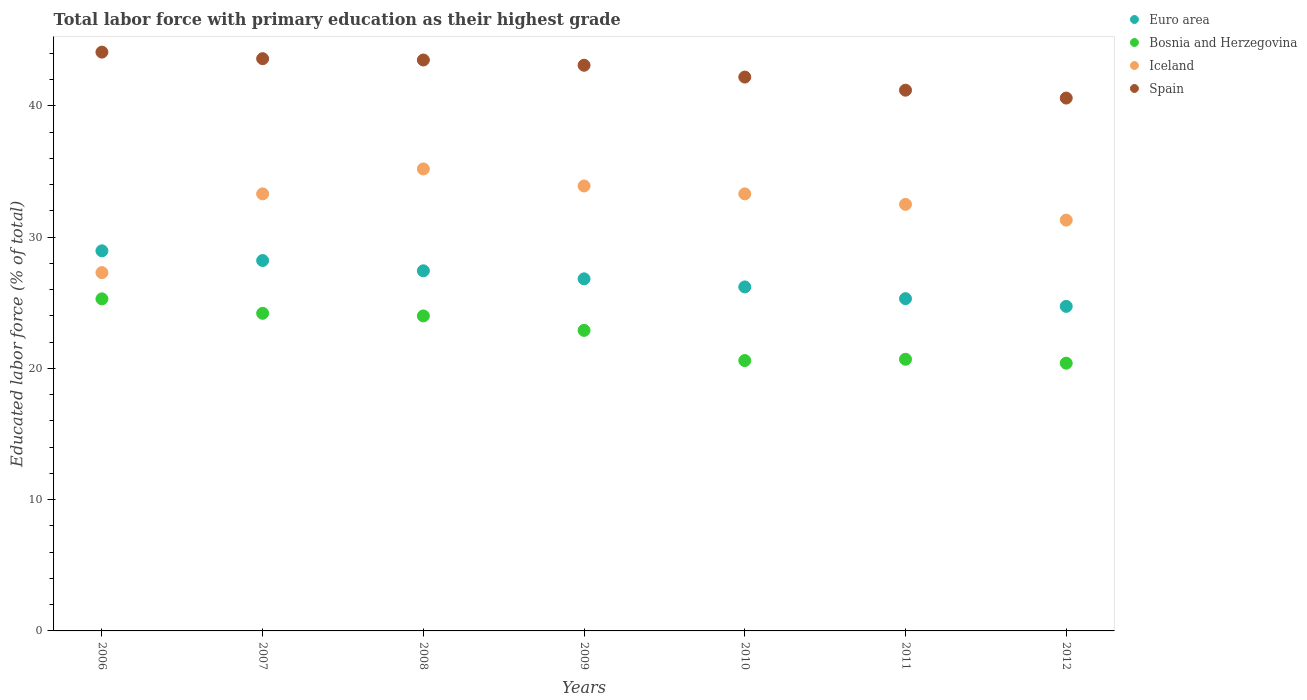How many different coloured dotlines are there?
Provide a succinct answer. 4. Is the number of dotlines equal to the number of legend labels?
Provide a succinct answer. Yes. What is the percentage of total labor force with primary education in Euro area in 2010?
Your answer should be compact. 26.21. Across all years, what is the maximum percentage of total labor force with primary education in Iceland?
Give a very brief answer. 35.2. Across all years, what is the minimum percentage of total labor force with primary education in Iceland?
Your response must be concise. 27.3. What is the total percentage of total labor force with primary education in Euro area in the graph?
Keep it short and to the point. 187.7. What is the difference between the percentage of total labor force with primary education in Spain in 2006 and that in 2011?
Your answer should be very brief. 2.9. What is the difference between the percentage of total labor force with primary education in Euro area in 2011 and the percentage of total labor force with primary education in Iceland in 2008?
Your response must be concise. -9.88. What is the average percentage of total labor force with primary education in Iceland per year?
Give a very brief answer. 32.4. In the year 2007, what is the difference between the percentage of total labor force with primary education in Euro area and percentage of total labor force with primary education in Bosnia and Herzegovina?
Your response must be concise. 4.02. In how many years, is the percentage of total labor force with primary education in Euro area greater than 8 %?
Provide a short and direct response. 7. What is the ratio of the percentage of total labor force with primary education in Euro area in 2010 to that in 2012?
Offer a very short reply. 1.06. Is the percentage of total labor force with primary education in Spain in 2008 less than that in 2010?
Ensure brevity in your answer.  No. Is the difference between the percentage of total labor force with primary education in Euro area in 2007 and 2012 greater than the difference between the percentage of total labor force with primary education in Bosnia and Herzegovina in 2007 and 2012?
Give a very brief answer. No. What is the difference between the highest and the second highest percentage of total labor force with primary education in Iceland?
Provide a short and direct response. 1.3. What is the difference between the highest and the lowest percentage of total labor force with primary education in Euro area?
Your answer should be compact. 4.23. Is it the case that in every year, the sum of the percentage of total labor force with primary education in Bosnia and Herzegovina and percentage of total labor force with primary education in Euro area  is greater than the sum of percentage of total labor force with primary education in Spain and percentage of total labor force with primary education in Iceland?
Provide a succinct answer. Yes. Is it the case that in every year, the sum of the percentage of total labor force with primary education in Iceland and percentage of total labor force with primary education in Euro area  is greater than the percentage of total labor force with primary education in Spain?
Your response must be concise. Yes. Is the percentage of total labor force with primary education in Spain strictly greater than the percentage of total labor force with primary education in Bosnia and Herzegovina over the years?
Provide a short and direct response. Yes. Does the graph contain any zero values?
Your answer should be very brief. No. Where does the legend appear in the graph?
Offer a terse response. Top right. How many legend labels are there?
Provide a short and direct response. 4. How are the legend labels stacked?
Make the answer very short. Vertical. What is the title of the graph?
Offer a terse response. Total labor force with primary education as their highest grade. Does "Israel" appear as one of the legend labels in the graph?
Keep it short and to the point. No. What is the label or title of the Y-axis?
Provide a short and direct response. Educated labor force (% of total). What is the Educated labor force (% of total) in Euro area in 2006?
Offer a terse response. 28.96. What is the Educated labor force (% of total) of Bosnia and Herzegovina in 2006?
Offer a terse response. 25.3. What is the Educated labor force (% of total) in Iceland in 2006?
Ensure brevity in your answer.  27.3. What is the Educated labor force (% of total) of Spain in 2006?
Offer a terse response. 44.1. What is the Educated labor force (% of total) of Euro area in 2007?
Keep it short and to the point. 28.22. What is the Educated labor force (% of total) of Bosnia and Herzegovina in 2007?
Your answer should be compact. 24.2. What is the Educated labor force (% of total) in Iceland in 2007?
Offer a terse response. 33.3. What is the Educated labor force (% of total) in Spain in 2007?
Keep it short and to the point. 43.6. What is the Educated labor force (% of total) in Euro area in 2008?
Offer a terse response. 27.44. What is the Educated labor force (% of total) of Bosnia and Herzegovina in 2008?
Keep it short and to the point. 24. What is the Educated labor force (% of total) of Iceland in 2008?
Offer a very short reply. 35.2. What is the Educated labor force (% of total) of Spain in 2008?
Provide a short and direct response. 43.5. What is the Educated labor force (% of total) in Euro area in 2009?
Make the answer very short. 26.83. What is the Educated labor force (% of total) in Bosnia and Herzegovina in 2009?
Offer a terse response. 22.9. What is the Educated labor force (% of total) of Iceland in 2009?
Provide a short and direct response. 33.9. What is the Educated labor force (% of total) of Spain in 2009?
Make the answer very short. 43.1. What is the Educated labor force (% of total) in Euro area in 2010?
Your answer should be very brief. 26.21. What is the Educated labor force (% of total) of Bosnia and Herzegovina in 2010?
Your response must be concise. 20.6. What is the Educated labor force (% of total) in Iceland in 2010?
Your answer should be compact. 33.3. What is the Educated labor force (% of total) in Spain in 2010?
Offer a very short reply. 42.2. What is the Educated labor force (% of total) in Euro area in 2011?
Make the answer very short. 25.32. What is the Educated labor force (% of total) of Bosnia and Herzegovina in 2011?
Offer a very short reply. 20.7. What is the Educated labor force (% of total) of Iceland in 2011?
Your response must be concise. 32.5. What is the Educated labor force (% of total) of Spain in 2011?
Your answer should be very brief. 41.2. What is the Educated labor force (% of total) of Euro area in 2012?
Provide a short and direct response. 24.73. What is the Educated labor force (% of total) in Bosnia and Herzegovina in 2012?
Give a very brief answer. 20.4. What is the Educated labor force (% of total) of Iceland in 2012?
Ensure brevity in your answer.  31.3. What is the Educated labor force (% of total) in Spain in 2012?
Offer a very short reply. 40.6. Across all years, what is the maximum Educated labor force (% of total) of Euro area?
Provide a succinct answer. 28.96. Across all years, what is the maximum Educated labor force (% of total) in Bosnia and Herzegovina?
Your answer should be compact. 25.3. Across all years, what is the maximum Educated labor force (% of total) in Iceland?
Offer a terse response. 35.2. Across all years, what is the maximum Educated labor force (% of total) in Spain?
Provide a short and direct response. 44.1. Across all years, what is the minimum Educated labor force (% of total) of Euro area?
Provide a succinct answer. 24.73. Across all years, what is the minimum Educated labor force (% of total) of Bosnia and Herzegovina?
Keep it short and to the point. 20.4. Across all years, what is the minimum Educated labor force (% of total) of Iceland?
Your answer should be very brief. 27.3. Across all years, what is the minimum Educated labor force (% of total) in Spain?
Ensure brevity in your answer.  40.6. What is the total Educated labor force (% of total) in Euro area in the graph?
Offer a terse response. 187.7. What is the total Educated labor force (% of total) of Bosnia and Herzegovina in the graph?
Ensure brevity in your answer.  158.1. What is the total Educated labor force (% of total) of Iceland in the graph?
Your answer should be very brief. 226.8. What is the total Educated labor force (% of total) in Spain in the graph?
Make the answer very short. 298.3. What is the difference between the Educated labor force (% of total) of Euro area in 2006 and that in 2007?
Your answer should be compact. 0.74. What is the difference between the Educated labor force (% of total) of Spain in 2006 and that in 2007?
Your answer should be very brief. 0.5. What is the difference between the Educated labor force (% of total) in Euro area in 2006 and that in 2008?
Make the answer very short. 1.52. What is the difference between the Educated labor force (% of total) of Bosnia and Herzegovina in 2006 and that in 2008?
Offer a terse response. 1.3. What is the difference between the Educated labor force (% of total) of Iceland in 2006 and that in 2008?
Provide a succinct answer. -7.9. What is the difference between the Educated labor force (% of total) in Spain in 2006 and that in 2008?
Provide a succinct answer. 0.6. What is the difference between the Educated labor force (% of total) in Euro area in 2006 and that in 2009?
Give a very brief answer. 2.13. What is the difference between the Educated labor force (% of total) in Euro area in 2006 and that in 2010?
Offer a very short reply. 2.75. What is the difference between the Educated labor force (% of total) in Spain in 2006 and that in 2010?
Offer a terse response. 1.9. What is the difference between the Educated labor force (% of total) in Euro area in 2006 and that in 2011?
Offer a very short reply. 3.64. What is the difference between the Educated labor force (% of total) of Euro area in 2006 and that in 2012?
Provide a short and direct response. 4.23. What is the difference between the Educated labor force (% of total) in Bosnia and Herzegovina in 2006 and that in 2012?
Provide a short and direct response. 4.9. What is the difference between the Educated labor force (% of total) of Iceland in 2006 and that in 2012?
Your response must be concise. -4. What is the difference between the Educated labor force (% of total) of Spain in 2006 and that in 2012?
Your answer should be compact. 3.5. What is the difference between the Educated labor force (% of total) in Euro area in 2007 and that in 2008?
Offer a very short reply. 0.78. What is the difference between the Educated labor force (% of total) in Bosnia and Herzegovina in 2007 and that in 2008?
Ensure brevity in your answer.  0.2. What is the difference between the Educated labor force (% of total) in Iceland in 2007 and that in 2008?
Offer a very short reply. -1.9. What is the difference between the Educated labor force (% of total) in Euro area in 2007 and that in 2009?
Give a very brief answer. 1.4. What is the difference between the Educated labor force (% of total) in Euro area in 2007 and that in 2010?
Your response must be concise. 2.01. What is the difference between the Educated labor force (% of total) in Bosnia and Herzegovina in 2007 and that in 2010?
Give a very brief answer. 3.6. What is the difference between the Educated labor force (% of total) of Euro area in 2007 and that in 2011?
Offer a very short reply. 2.9. What is the difference between the Educated labor force (% of total) of Bosnia and Herzegovina in 2007 and that in 2011?
Your answer should be compact. 3.5. What is the difference between the Educated labor force (% of total) of Iceland in 2007 and that in 2011?
Your response must be concise. 0.8. What is the difference between the Educated labor force (% of total) of Euro area in 2007 and that in 2012?
Provide a short and direct response. 3.49. What is the difference between the Educated labor force (% of total) in Iceland in 2007 and that in 2012?
Keep it short and to the point. 2. What is the difference between the Educated labor force (% of total) in Euro area in 2008 and that in 2009?
Offer a terse response. 0.61. What is the difference between the Educated labor force (% of total) in Spain in 2008 and that in 2009?
Give a very brief answer. 0.4. What is the difference between the Educated labor force (% of total) of Euro area in 2008 and that in 2010?
Ensure brevity in your answer.  1.23. What is the difference between the Educated labor force (% of total) of Bosnia and Herzegovina in 2008 and that in 2010?
Ensure brevity in your answer.  3.4. What is the difference between the Educated labor force (% of total) of Spain in 2008 and that in 2010?
Your answer should be compact. 1.3. What is the difference between the Educated labor force (% of total) of Euro area in 2008 and that in 2011?
Ensure brevity in your answer.  2.12. What is the difference between the Educated labor force (% of total) in Iceland in 2008 and that in 2011?
Your answer should be very brief. 2.7. What is the difference between the Educated labor force (% of total) of Euro area in 2008 and that in 2012?
Provide a short and direct response. 2.71. What is the difference between the Educated labor force (% of total) in Iceland in 2008 and that in 2012?
Keep it short and to the point. 3.9. What is the difference between the Educated labor force (% of total) in Spain in 2008 and that in 2012?
Your answer should be compact. 2.9. What is the difference between the Educated labor force (% of total) in Euro area in 2009 and that in 2010?
Offer a terse response. 0.62. What is the difference between the Educated labor force (% of total) in Bosnia and Herzegovina in 2009 and that in 2010?
Your response must be concise. 2.3. What is the difference between the Educated labor force (% of total) in Spain in 2009 and that in 2010?
Your answer should be compact. 0.9. What is the difference between the Educated labor force (% of total) in Euro area in 2009 and that in 2011?
Offer a very short reply. 1.51. What is the difference between the Educated labor force (% of total) in Bosnia and Herzegovina in 2009 and that in 2011?
Provide a succinct answer. 2.2. What is the difference between the Educated labor force (% of total) of Euro area in 2009 and that in 2012?
Your response must be concise. 2.1. What is the difference between the Educated labor force (% of total) of Bosnia and Herzegovina in 2009 and that in 2012?
Keep it short and to the point. 2.5. What is the difference between the Educated labor force (% of total) in Iceland in 2009 and that in 2012?
Offer a very short reply. 2.6. What is the difference between the Educated labor force (% of total) of Spain in 2009 and that in 2012?
Your answer should be very brief. 2.5. What is the difference between the Educated labor force (% of total) in Euro area in 2010 and that in 2011?
Keep it short and to the point. 0.89. What is the difference between the Educated labor force (% of total) of Bosnia and Herzegovina in 2010 and that in 2011?
Your answer should be very brief. -0.1. What is the difference between the Educated labor force (% of total) of Iceland in 2010 and that in 2011?
Provide a short and direct response. 0.8. What is the difference between the Educated labor force (% of total) of Euro area in 2010 and that in 2012?
Offer a very short reply. 1.48. What is the difference between the Educated labor force (% of total) of Bosnia and Herzegovina in 2010 and that in 2012?
Offer a very short reply. 0.2. What is the difference between the Educated labor force (% of total) of Euro area in 2011 and that in 2012?
Keep it short and to the point. 0.59. What is the difference between the Educated labor force (% of total) of Spain in 2011 and that in 2012?
Give a very brief answer. 0.6. What is the difference between the Educated labor force (% of total) of Euro area in 2006 and the Educated labor force (% of total) of Bosnia and Herzegovina in 2007?
Make the answer very short. 4.76. What is the difference between the Educated labor force (% of total) in Euro area in 2006 and the Educated labor force (% of total) in Iceland in 2007?
Provide a short and direct response. -4.34. What is the difference between the Educated labor force (% of total) in Euro area in 2006 and the Educated labor force (% of total) in Spain in 2007?
Provide a short and direct response. -14.64. What is the difference between the Educated labor force (% of total) of Bosnia and Herzegovina in 2006 and the Educated labor force (% of total) of Spain in 2007?
Keep it short and to the point. -18.3. What is the difference between the Educated labor force (% of total) in Iceland in 2006 and the Educated labor force (% of total) in Spain in 2007?
Offer a terse response. -16.3. What is the difference between the Educated labor force (% of total) in Euro area in 2006 and the Educated labor force (% of total) in Bosnia and Herzegovina in 2008?
Ensure brevity in your answer.  4.96. What is the difference between the Educated labor force (% of total) in Euro area in 2006 and the Educated labor force (% of total) in Iceland in 2008?
Your answer should be compact. -6.24. What is the difference between the Educated labor force (% of total) in Euro area in 2006 and the Educated labor force (% of total) in Spain in 2008?
Your answer should be very brief. -14.54. What is the difference between the Educated labor force (% of total) of Bosnia and Herzegovina in 2006 and the Educated labor force (% of total) of Spain in 2008?
Provide a short and direct response. -18.2. What is the difference between the Educated labor force (% of total) of Iceland in 2006 and the Educated labor force (% of total) of Spain in 2008?
Your response must be concise. -16.2. What is the difference between the Educated labor force (% of total) of Euro area in 2006 and the Educated labor force (% of total) of Bosnia and Herzegovina in 2009?
Your answer should be compact. 6.06. What is the difference between the Educated labor force (% of total) of Euro area in 2006 and the Educated labor force (% of total) of Iceland in 2009?
Offer a terse response. -4.94. What is the difference between the Educated labor force (% of total) in Euro area in 2006 and the Educated labor force (% of total) in Spain in 2009?
Provide a short and direct response. -14.14. What is the difference between the Educated labor force (% of total) in Bosnia and Herzegovina in 2006 and the Educated labor force (% of total) in Iceland in 2009?
Offer a very short reply. -8.6. What is the difference between the Educated labor force (% of total) in Bosnia and Herzegovina in 2006 and the Educated labor force (% of total) in Spain in 2009?
Offer a terse response. -17.8. What is the difference between the Educated labor force (% of total) in Iceland in 2006 and the Educated labor force (% of total) in Spain in 2009?
Your answer should be compact. -15.8. What is the difference between the Educated labor force (% of total) in Euro area in 2006 and the Educated labor force (% of total) in Bosnia and Herzegovina in 2010?
Offer a terse response. 8.36. What is the difference between the Educated labor force (% of total) in Euro area in 2006 and the Educated labor force (% of total) in Iceland in 2010?
Your response must be concise. -4.34. What is the difference between the Educated labor force (% of total) in Euro area in 2006 and the Educated labor force (% of total) in Spain in 2010?
Provide a succinct answer. -13.24. What is the difference between the Educated labor force (% of total) of Bosnia and Herzegovina in 2006 and the Educated labor force (% of total) of Spain in 2010?
Keep it short and to the point. -16.9. What is the difference between the Educated labor force (% of total) of Iceland in 2006 and the Educated labor force (% of total) of Spain in 2010?
Provide a succinct answer. -14.9. What is the difference between the Educated labor force (% of total) of Euro area in 2006 and the Educated labor force (% of total) of Bosnia and Herzegovina in 2011?
Provide a succinct answer. 8.26. What is the difference between the Educated labor force (% of total) of Euro area in 2006 and the Educated labor force (% of total) of Iceland in 2011?
Ensure brevity in your answer.  -3.54. What is the difference between the Educated labor force (% of total) of Euro area in 2006 and the Educated labor force (% of total) of Spain in 2011?
Your answer should be compact. -12.24. What is the difference between the Educated labor force (% of total) in Bosnia and Herzegovina in 2006 and the Educated labor force (% of total) in Spain in 2011?
Offer a terse response. -15.9. What is the difference between the Educated labor force (% of total) in Euro area in 2006 and the Educated labor force (% of total) in Bosnia and Herzegovina in 2012?
Offer a very short reply. 8.56. What is the difference between the Educated labor force (% of total) of Euro area in 2006 and the Educated labor force (% of total) of Iceland in 2012?
Keep it short and to the point. -2.34. What is the difference between the Educated labor force (% of total) of Euro area in 2006 and the Educated labor force (% of total) of Spain in 2012?
Provide a succinct answer. -11.64. What is the difference between the Educated labor force (% of total) of Bosnia and Herzegovina in 2006 and the Educated labor force (% of total) of Iceland in 2012?
Offer a terse response. -6. What is the difference between the Educated labor force (% of total) of Bosnia and Herzegovina in 2006 and the Educated labor force (% of total) of Spain in 2012?
Your response must be concise. -15.3. What is the difference between the Educated labor force (% of total) of Euro area in 2007 and the Educated labor force (% of total) of Bosnia and Herzegovina in 2008?
Make the answer very short. 4.22. What is the difference between the Educated labor force (% of total) of Euro area in 2007 and the Educated labor force (% of total) of Iceland in 2008?
Make the answer very short. -6.98. What is the difference between the Educated labor force (% of total) in Euro area in 2007 and the Educated labor force (% of total) in Spain in 2008?
Ensure brevity in your answer.  -15.28. What is the difference between the Educated labor force (% of total) of Bosnia and Herzegovina in 2007 and the Educated labor force (% of total) of Spain in 2008?
Your answer should be compact. -19.3. What is the difference between the Educated labor force (% of total) of Iceland in 2007 and the Educated labor force (% of total) of Spain in 2008?
Ensure brevity in your answer.  -10.2. What is the difference between the Educated labor force (% of total) of Euro area in 2007 and the Educated labor force (% of total) of Bosnia and Herzegovina in 2009?
Your response must be concise. 5.32. What is the difference between the Educated labor force (% of total) of Euro area in 2007 and the Educated labor force (% of total) of Iceland in 2009?
Give a very brief answer. -5.68. What is the difference between the Educated labor force (% of total) of Euro area in 2007 and the Educated labor force (% of total) of Spain in 2009?
Give a very brief answer. -14.88. What is the difference between the Educated labor force (% of total) of Bosnia and Herzegovina in 2007 and the Educated labor force (% of total) of Spain in 2009?
Ensure brevity in your answer.  -18.9. What is the difference between the Educated labor force (% of total) of Euro area in 2007 and the Educated labor force (% of total) of Bosnia and Herzegovina in 2010?
Your response must be concise. 7.62. What is the difference between the Educated labor force (% of total) in Euro area in 2007 and the Educated labor force (% of total) in Iceland in 2010?
Your response must be concise. -5.08. What is the difference between the Educated labor force (% of total) in Euro area in 2007 and the Educated labor force (% of total) in Spain in 2010?
Provide a short and direct response. -13.98. What is the difference between the Educated labor force (% of total) in Bosnia and Herzegovina in 2007 and the Educated labor force (% of total) in Iceland in 2010?
Offer a very short reply. -9.1. What is the difference between the Educated labor force (% of total) in Bosnia and Herzegovina in 2007 and the Educated labor force (% of total) in Spain in 2010?
Ensure brevity in your answer.  -18. What is the difference between the Educated labor force (% of total) of Euro area in 2007 and the Educated labor force (% of total) of Bosnia and Herzegovina in 2011?
Make the answer very short. 7.52. What is the difference between the Educated labor force (% of total) in Euro area in 2007 and the Educated labor force (% of total) in Iceland in 2011?
Your answer should be compact. -4.28. What is the difference between the Educated labor force (% of total) in Euro area in 2007 and the Educated labor force (% of total) in Spain in 2011?
Provide a short and direct response. -12.98. What is the difference between the Educated labor force (% of total) of Bosnia and Herzegovina in 2007 and the Educated labor force (% of total) of Spain in 2011?
Your answer should be very brief. -17. What is the difference between the Educated labor force (% of total) in Euro area in 2007 and the Educated labor force (% of total) in Bosnia and Herzegovina in 2012?
Offer a terse response. 7.82. What is the difference between the Educated labor force (% of total) of Euro area in 2007 and the Educated labor force (% of total) of Iceland in 2012?
Your answer should be very brief. -3.08. What is the difference between the Educated labor force (% of total) in Euro area in 2007 and the Educated labor force (% of total) in Spain in 2012?
Your answer should be very brief. -12.38. What is the difference between the Educated labor force (% of total) in Bosnia and Herzegovina in 2007 and the Educated labor force (% of total) in Spain in 2012?
Ensure brevity in your answer.  -16.4. What is the difference between the Educated labor force (% of total) in Iceland in 2007 and the Educated labor force (% of total) in Spain in 2012?
Offer a terse response. -7.3. What is the difference between the Educated labor force (% of total) of Euro area in 2008 and the Educated labor force (% of total) of Bosnia and Herzegovina in 2009?
Offer a terse response. 4.54. What is the difference between the Educated labor force (% of total) in Euro area in 2008 and the Educated labor force (% of total) in Iceland in 2009?
Your response must be concise. -6.46. What is the difference between the Educated labor force (% of total) of Euro area in 2008 and the Educated labor force (% of total) of Spain in 2009?
Ensure brevity in your answer.  -15.66. What is the difference between the Educated labor force (% of total) in Bosnia and Herzegovina in 2008 and the Educated labor force (% of total) in Iceland in 2009?
Your answer should be compact. -9.9. What is the difference between the Educated labor force (% of total) of Bosnia and Herzegovina in 2008 and the Educated labor force (% of total) of Spain in 2009?
Offer a terse response. -19.1. What is the difference between the Educated labor force (% of total) of Euro area in 2008 and the Educated labor force (% of total) of Bosnia and Herzegovina in 2010?
Keep it short and to the point. 6.84. What is the difference between the Educated labor force (% of total) in Euro area in 2008 and the Educated labor force (% of total) in Iceland in 2010?
Your response must be concise. -5.86. What is the difference between the Educated labor force (% of total) of Euro area in 2008 and the Educated labor force (% of total) of Spain in 2010?
Your response must be concise. -14.76. What is the difference between the Educated labor force (% of total) in Bosnia and Herzegovina in 2008 and the Educated labor force (% of total) in Spain in 2010?
Provide a short and direct response. -18.2. What is the difference between the Educated labor force (% of total) of Euro area in 2008 and the Educated labor force (% of total) of Bosnia and Herzegovina in 2011?
Keep it short and to the point. 6.74. What is the difference between the Educated labor force (% of total) in Euro area in 2008 and the Educated labor force (% of total) in Iceland in 2011?
Ensure brevity in your answer.  -5.06. What is the difference between the Educated labor force (% of total) in Euro area in 2008 and the Educated labor force (% of total) in Spain in 2011?
Make the answer very short. -13.76. What is the difference between the Educated labor force (% of total) of Bosnia and Herzegovina in 2008 and the Educated labor force (% of total) of Spain in 2011?
Give a very brief answer. -17.2. What is the difference between the Educated labor force (% of total) in Euro area in 2008 and the Educated labor force (% of total) in Bosnia and Herzegovina in 2012?
Provide a short and direct response. 7.04. What is the difference between the Educated labor force (% of total) in Euro area in 2008 and the Educated labor force (% of total) in Iceland in 2012?
Give a very brief answer. -3.86. What is the difference between the Educated labor force (% of total) of Euro area in 2008 and the Educated labor force (% of total) of Spain in 2012?
Offer a terse response. -13.16. What is the difference between the Educated labor force (% of total) in Bosnia and Herzegovina in 2008 and the Educated labor force (% of total) in Spain in 2012?
Your answer should be compact. -16.6. What is the difference between the Educated labor force (% of total) of Iceland in 2008 and the Educated labor force (% of total) of Spain in 2012?
Your answer should be very brief. -5.4. What is the difference between the Educated labor force (% of total) of Euro area in 2009 and the Educated labor force (% of total) of Bosnia and Herzegovina in 2010?
Offer a very short reply. 6.23. What is the difference between the Educated labor force (% of total) of Euro area in 2009 and the Educated labor force (% of total) of Iceland in 2010?
Ensure brevity in your answer.  -6.47. What is the difference between the Educated labor force (% of total) in Euro area in 2009 and the Educated labor force (% of total) in Spain in 2010?
Your answer should be compact. -15.37. What is the difference between the Educated labor force (% of total) in Bosnia and Herzegovina in 2009 and the Educated labor force (% of total) in Iceland in 2010?
Your answer should be compact. -10.4. What is the difference between the Educated labor force (% of total) in Bosnia and Herzegovina in 2009 and the Educated labor force (% of total) in Spain in 2010?
Give a very brief answer. -19.3. What is the difference between the Educated labor force (% of total) of Iceland in 2009 and the Educated labor force (% of total) of Spain in 2010?
Make the answer very short. -8.3. What is the difference between the Educated labor force (% of total) in Euro area in 2009 and the Educated labor force (% of total) in Bosnia and Herzegovina in 2011?
Offer a terse response. 6.13. What is the difference between the Educated labor force (% of total) in Euro area in 2009 and the Educated labor force (% of total) in Iceland in 2011?
Your response must be concise. -5.67. What is the difference between the Educated labor force (% of total) in Euro area in 2009 and the Educated labor force (% of total) in Spain in 2011?
Ensure brevity in your answer.  -14.37. What is the difference between the Educated labor force (% of total) of Bosnia and Herzegovina in 2009 and the Educated labor force (% of total) of Spain in 2011?
Offer a terse response. -18.3. What is the difference between the Educated labor force (% of total) of Iceland in 2009 and the Educated labor force (% of total) of Spain in 2011?
Keep it short and to the point. -7.3. What is the difference between the Educated labor force (% of total) of Euro area in 2009 and the Educated labor force (% of total) of Bosnia and Herzegovina in 2012?
Offer a terse response. 6.43. What is the difference between the Educated labor force (% of total) in Euro area in 2009 and the Educated labor force (% of total) in Iceland in 2012?
Your response must be concise. -4.47. What is the difference between the Educated labor force (% of total) in Euro area in 2009 and the Educated labor force (% of total) in Spain in 2012?
Keep it short and to the point. -13.77. What is the difference between the Educated labor force (% of total) in Bosnia and Herzegovina in 2009 and the Educated labor force (% of total) in Spain in 2012?
Ensure brevity in your answer.  -17.7. What is the difference between the Educated labor force (% of total) of Iceland in 2009 and the Educated labor force (% of total) of Spain in 2012?
Give a very brief answer. -6.7. What is the difference between the Educated labor force (% of total) of Euro area in 2010 and the Educated labor force (% of total) of Bosnia and Herzegovina in 2011?
Provide a short and direct response. 5.51. What is the difference between the Educated labor force (% of total) of Euro area in 2010 and the Educated labor force (% of total) of Iceland in 2011?
Give a very brief answer. -6.29. What is the difference between the Educated labor force (% of total) of Euro area in 2010 and the Educated labor force (% of total) of Spain in 2011?
Ensure brevity in your answer.  -14.99. What is the difference between the Educated labor force (% of total) in Bosnia and Herzegovina in 2010 and the Educated labor force (% of total) in Iceland in 2011?
Your answer should be very brief. -11.9. What is the difference between the Educated labor force (% of total) in Bosnia and Herzegovina in 2010 and the Educated labor force (% of total) in Spain in 2011?
Provide a short and direct response. -20.6. What is the difference between the Educated labor force (% of total) of Iceland in 2010 and the Educated labor force (% of total) of Spain in 2011?
Offer a terse response. -7.9. What is the difference between the Educated labor force (% of total) in Euro area in 2010 and the Educated labor force (% of total) in Bosnia and Herzegovina in 2012?
Ensure brevity in your answer.  5.81. What is the difference between the Educated labor force (% of total) of Euro area in 2010 and the Educated labor force (% of total) of Iceland in 2012?
Your response must be concise. -5.09. What is the difference between the Educated labor force (% of total) in Euro area in 2010 and the Educated labor force (% of total) in Spain in 2012?
Give a very brief answer. -14.39. What is the difference between the Educated labor force (% of total) in Bosnia and Herzegovina in 2010 and the Educated labor force (% of total) in Iceland in 2012?
Provide a succinct answer. -10.7. What is the difference between the Educated labor force (% of total) of Bosnia and Herzegovina in 2010 and the Educated labor force (% of total) of Spain in 2012?
Your answer should be very brief. -20. What is the difference between the Educated labor force (% of total) in Iceland in 2010 and the Educated labor force (% of total) in Spain in 2012?
Offer a very short reply. -7.3. What is the difference between the Educated labor force (% of total) in Euro area in 2011 and the Educated labor force (% of total) in Bosnia and Herzegovina in 2012?
Keep it short and to the point. 4.92. What is the difference between the Educated labor force (% of total) of Euro area in 2011 and the Educated labor force (% of total) of Iceland in 2012?
Provide a succinct answer. -5.98. What is the difference between the Educated labor force (% of total) in Euro area in 2011 and the Educated labor force (% of total) in Spain in 2012?
Offer a terse response. -15.28. What is the difference between the Educated labor force (% of total) in Bosnia and Herzegovina in 2011 and the Educated labor force (% of total) in Iceland in 2012?
Offer a terse response. -10.6. What is the difference between the Educated labor force (% of total) in Bosnia and Herzegovina in 2011 and the Educated labor force (% of total) in Spain in 2012?
Keep it short and to the point. -19.9. What is the average Educated labor force (% of total) of Euro area per year?
Keep it short and to the point. 26.81. What is the average Educated labor force (% of total) in Bosnia and Herzegovina per year?
Make the answer very short. 22.59. What is the average Educated labor force (% of total) in Iceland per year?
Give a very brief answer. 32.4. What is the average Educated labor force (% of total) of Spain per year?
Your answer should be compact. 42.61. In the year 2006, what is the difference between the Educated labor force (% of total) of Euro area and Educated labor force (% of total) of Bosnia and Herzegovina?
Make the answer very short. 3.66. In the year 2006, what is the difference between the Educated labor force (% of total) in Euro area and Educated labor force (% of total) in Iceland?
Provide a succinct answer. 1.66. In the year 2006, what is the difference between the Educated labor force (% of total) of Euro area and Educated labor force (% of total) of Spain?
Offer a very short reply. -15.14. In the year 2006, what is the difference between the Educated labor force (% of total) of Bosnia and Herzegovina and Educated labor force (% of total) of Spain?
Provide a short and direct response. -18.8. In the year 2006, what is the difference between the Educated labor force (% of total) in Iceland and Educated labor force (% of total) in Spain?
Offer a terse response. -16.8. In the year 2007, what is the difference between the Educated labor force (% of total) of Euro area and Educated labor force (% of total) of Bosnia and Herzegovina?
Make the answer very short. 4.02. In the year 2007, what is the difference between the Educated labor force (% of total) in Euro area and Educated labor force (% of total) in Iceland?
Your answer should be very brief. -5.08. In the year 2007, what is the difference between the Educated labor force (% of total) of Euro area and Educated labor force (% of total) of Spain?
Make the answer very short. -15.38. In the year 2007, what is the difference between the Educated labor force (% of total) of Bosnia and Herzegovina and Educated labor force (% of total) of Iceland?
Your response must be concise. -9.1. In the year 2007, what is the difference between the Educated labor force (% of total) in Bosnia and Herzegovina and Educated labor force (% of total) in Spain?
Provide a short and direct response. -19.4. In the year 2008, what is the difference between the Educated labor force (% of total) in Euro area and Educated labor force (% of total) in Bosnia and Herzegovina?
Your answer should be compact. 3.44. In the year 2008, what is the difference between the Educated labor force (% of total) of Euro area and Educated labor force (% of total) of Iceland?
Make the answer very short. -7.76. In the year 2008, what is the difference between the Educated labor force (% of total) of Euro area and Educated labor force (% of total) of Spain?
Make the answer very short. -16.06. In the year 2008, what is the difference between the Educated labor force (% of total) of Bosnia and Herzegovina and Educated labor force (% of total) of Spain?
Keep it short and to the point. -19.5. In the year 2009, what is the difference between the Educated labor force (% of total) of Euro area and Educated labor force (% of total) of Bosnia and Herzegovina?
Make the answer very short. 3.93. In the year 2009, what is the difference between the Educated labor force (% of total) of Euro area and Educated labor force (% of total) of Iceland?
Offer a very short reply. -7.07. In the year 2009, what is the difference between the Educated labor force (% of total) of Euro area and Educated labor force (% of total) of Spain?
Provide a short and direct response. -16.27. In the year 2009, what is the difference between the Educated labor force (% of total) of Bosnia and Herzegovina and Educated labor force (% of total) of Spain?
Keep it short and to the point. -20.2. In the year 2010, what is the difference between the Educated labor force (% of total) of Euro area and Educated labor force (% of total) of Bosnia and Herzegovina?
Ensure brevity in your answer.  5.61. In the year 2010, what is the difference between the Educated labor force (% of total) of Euro area and Educated labor force (% of total) of Iceland?
Offer a terse response. -7.09. In the year 2010, what is the difference between the Educated labor force (% of total) in Euro area and Educated labor force (% of total) in Spain?
Provide a short and direct response. -15.99. In the year 2010, what is the difference between the Educated labor force (% of total) of Bosnia and Herzegovina and Educated labor force (% of total) of Iceland?
Provide a succinct answer. -12.7. In the year 2010, what is the difference between the Educated labor force (% of total) in Bosnia and Herzegovina and Educated labor force (% of total) in Spain?
Offer a very short reply. -21.6. In the year 2010, what is the difference between the Educated labor force (% of total) of Iceland and Educated labor force (% of total) of Spain?
Your answer should be compact. -8.9. In the year 2011, what is the difference between the Educated labor force (% of total) in Euro area and Educated labor force (% of total) in Bosnia and Herzegovina?
Make the answer very short. 4.62. In the year 2011, what is the difference between the Educated labor force (% of total) in Euro area and Educated labor force (% of total) in Iceland?
Your answer should be compact. -7.18. In the year 2011, what is the difference between the Educated labor force (% of total) in Euro area and Educated labor force (% of total) in Spain?
Provide a succinct answer. -15.88. In the year 2011, what is the difference between the Educated labor force (% of total) of Bosnia and Herzegovina and Educated labor force (% of total) of Spain?
Your answer should be very brief. -20.5. In the year 2012, what is the difference between the Educated labor force (% of total) of Euro area and Educated labor force (% of total) of Bosnia and Herzegovina?
Give a very brief answer. 4.33. In the year 2012, what is the difference between the Educated labor force (% of total) in Euro area and Educated labor force (% of total) in Iceland?
Your response must be concise. -6.57. In the year 2012, what is the difference between the Educated labor force (% of total) in Euro area and Educated labor force (% of total) in Spain?
Offer a terse response. -15.87. In the year 2012, what is the difference between the Educated labor force (% of total) of Bosnia and Herzegovina and Educated labor force (% of total) of Iceland?
Keep it short and to the point. -10.9. In the year 2012, what is the difference between the Educated labor force (% of total) of Bosnia and Herzegovina and Educated labor force (% of total) of Spain?
Your response must be concise. -20.2. In the year 2012, what is the difference between the Educated labor force (% of total) in Iceland and Educated labor force (% of total) in Spain?
Provide a short and direct response. -9.3. What is the ratio of the Educated labor force (% of total) of Euro area in 2006 to that in 2007?
Your answer should be compact. 1.03. What is the ratio of the Educated labor force (% of total) of Bosnia and Herzegovina in 2006 to that in 2007?
Provide a succinct answer. 1.05. What is the ratio of the Educated labor force (% of total) of Iceland in 2006 to that in 2007?
Provide a short and direct response. 0.82. What is the ratio of the Educated labor force (% of total) in Spain in 2006 to that in 2007?
Your answer should be compact. 1.01. What is the ratio of the Educated labor force (% of total) in Euro area in 2006 to that in 2008?
Ensure brevity in your answer.  1.06. What is the ratio of the Educated labor force (% of total) of Bosnia and Herzegovina in 2006 to that in 2008?
Provide a short and direct response. 1.05. What is the ratio of the Educated labor force (% of total) of Iceland in 2006 to that in 2008?
Your answer should be very brief. 0.78. What is the ratio of the Educated labor force (% of total) in Spain in 2006 to that in 2008?
Give a very brief answer. 1.01. What is the ratio of the Educated labor force (% of total) of Euro area in 2006 to that in 2009?
Make the answer very short. 1.08. What is the ratio of the Educated labor force (% of total) of Bosnia and Herzegovina in 2006 to that in 2009?
Your answer should be very brief. 1.1. What is the ratio of the Educated labor force (% of total) of Iceland in 2006 to that in 2009?
Make the answer very short. 0.81. What is the ratio of the Educated labor force (% of total) in Spain in 2006 to that in 2009?
Offer a very short reply. 1.02. What is the ratio of the Educated labor force (% of total) in Euro area in 2006 to that in 2010?
Your answer should be very brief. 1.1. What is the ratio of the Educated labor force (% of total) in Bosnia and Herzegovina in 2006 to that in 2010?
Give a very brief answer. 1.23. What is the ratio of the Educated labor force (% of total) of Iceland in 2006 to that in 2010?
Your response must be concise. 0.82. What is the ratio of the Educated labor force (% of total) of Spain in 2006 to that in 2010?
Provide a succinct answer. 1.04. What is the ratio of the Educated labor force (% of total) of Euro area in 2006 to that in 2011?
Keep it short and to the point. 1.14. What is the ratio of the Educated labor force (% of total) of Bosnia and Herzegovina in 2006 to that in 2011?
Provide a short and direct response. 1.22. What is the ratio of the Educated labor force (% of total) in Iceland in 2006 to that in 2011?
Keep it short and to the point. 0.84. What is the ratio of the Educated labor force (% of total) of Spain in 2006 to that in 2011?
Provide a succinct answer. 1.07. What is the ratio of the Educated labor force (% of total) of Euro area in 2006 to that in 2012?
Offer a very short reply. 1.17. What is the ratio of the Educated labor force (% of total) of Bosnia and Herzegovina in 2006 to that in 2012?
Give a very brief answer. 1.24. What is the ratio of the Educated labor force (% of total) of Iceland in 2006 to that in 2012?
Your answer should be compact. 0.87. What is the ratio of the Educated labor force (% of total) in Spain in 2006 to that in 2012?
Offer a very short reply. 1.09. What is the ratio of the Educated labor force (% of total) of Euro area in 2007 to that in 2008?
Offer a terse response. 1.03. What is the ratio of the Educated labor force (% of total) of Bosnia and Herzegovina in 2007 to that in 2008?
Provide a succinct answer. 1.01. What is the ratio of the Educated labor force (% of total) in Iceland in 2007 to that in 2008?
Offer a terse response. 0.95. What is the ratio of the Educated labor force (% of total) of Spain in 2007 to that in 2008?
Offer a terse response. 1. What is the ratio of the Educated labor force (% of total) of Euro area in 2007 to that in 2009?
Offer a terse response. 1.05. What is the ratio of the Educated labor force (% of total) in Bosnia and Herzegovina in 2007 to that in 2009?
Provide a succinct answer. 1.06. What is the ratio of the Educated labor force (% of total) in Iceland in 2007 to that in 2009?
Keep it short and to the point. 0.98. What is the ratio of the Educated labor force (% of total) of Spain in 2007 to that in 2009?
Your answer should be compact. 1.01. What is the ratio of the Educated labor force (% of total) in Euro area in 2007 to that in 2010?
Offer a terse response. 1.08. What is the ratio of the Educated labor force (% of total) in Bosnia and Herzegovina in 2007 to that in 2010?
Your response must be concise. 1.17. What is the ratio of the Educated labor force (% of total) of Iceland in 2007 to that in 2010?
Provide a succinct answer. 1. What is the ratio of the Educated labor force (% of total) in Spain in 2007 to that in 2010?
Ensure brevity in your answer.  1.03. What is the ratio of the Educated labor force (% of total) in Euro area in 2007 to that in 2011?
Provide a short and direct response. 1.11. What is the ratio of the Educated labor force (% of total) in Bosnia and Herzegovina in 2007 to that in 2011?
Make the answer very short. 1.17. What is the ratio of the Educated labor force (% of total) of Iceland in 2007 to that in 2011?
Keep it short and to the point. 1.02. What is the ratio of the Educated labor force (% of total) in Spain in 2007 to that in 2011?
Keep it short and to the point. 1.06. What is the ratio of the Educated labor force (% of total) in Euro area in 2007 to that in 2012?
Give a very brief answer. 1.14. What is the ratio of the Educated labor force (% of total) of Bosnia and Herzegovina in 2007 to that in 2012?
Your response must be concise. 1.19. What is the ratio of the Educated labor force (% of total) in Iceland in 2007 to that in 2012?
Offer a very short reply. 1.06. What is the ratio of the Educated labor force (% of total) in Spain in 2007 to that in 2012?
Keep it short and to the point. 1.07. What is the ratio of the Educated labor force (% of total) of Euro area in 2008 to that in 2009?
Your answer should be very brief. 1.02. What is the ratio of the Educated labor force (% of total) in Bosnia and Herzegovina in 2008 to that in 2009?
Offer a very short reply. 1.05. What is the ratio of the Educated labor force (% of total) in Iceland in 2008 to that in 2009?
Make the answer very short. 1.04. What is the ratio of the Educated labor force (% of total) of Spain in 2008 to that in 2009?
Provide a succinct answer. 1.01. What is the ratio of the Educated labor force (% of total) in Euro area in 2008 to that in 2010?
Give a very brief answer. 1.05. What is the ratio of the Educated labor force (% of total) of Bosnia and Herzegovina in 2008 to that in 2010?
Offer a terse response. 1.17. What is the ratio of the Educated labor force (% of total) in Iceland in 2008 to that in 2010?
Your answer should be very brief. 1.06. What is the ratio of the Educated labor force (% of total) in Spain in 2008 to that in 2010?
Make the answer very short. 1.03. What is the ratio of the Educated labor force (% of total) in Euro area in 2008 to that in 2011?
Offer a very short reply. 1.08. What is the ratio of the Educated labor force (% of total) of Bosnia and Herzegovina in 2008 to that in 2011?
Your response must be concise. 1.16. What is the ratio of the Educated labor force (% of total) of Iceland in 2008 to that in 2011?
Your answer should be compact. 1.08. What is the ratio of the Educated labor force (% of total) of Spain in 2008 to that in 2011?
Give a very brief answer. 1.06. What is the ratio of the Educated labor force (% of total) in Euro area in 2008 to that in 2012?
Make the answer very short. 1.11. What is the ratio of the Educated labor force (% of total) of Bosnia and Herzegovina in 2008 to that in 2012?
Your answer should be compact. 1.18. What is the ratio of the Educated labor force (% of total) in Iceland in 2008 to that in 2012?
Your answer should be compact. 1.12. What is the ratio of the Educated labor force (% of total) of Spain in 2008 to that in 2012?
Give a very brief answer. 1.07. What is the ratio of the Educated labor force (% of total) in Euro area in 2009 to that in 2010?
Give a very brief answer. 1.02. What is the ratio of the Educated labor force (% of total) of Bosnia and Herzegovina in 2009 to that in 2010?
Your answer should be very brief. 1.11. What is the ratio of the Educated labor force (% of total) in Iceland in 2009 to that in 2010?
Make the answer very short. 1.02. What is the ratio of the Educated labor force (% of total) in Spain in 2009 to that in 2010?
Provide a succinct answer. 1.02. What is the ratio of the Educated labor force (% of total) in Euro area in 2009 to that in 2011?
Provide a succinct answer. 1.06. What is the ratio of the Educated labor force (% of total) in Bosnia and Herzegovina in 2009 to that in 2011?
Provide a succinct answer. 1.11. What is the ratio of the Educated labor force (% of total) in Iceland in 2009 to that in 2011?
Give a very brief answer. 1.04. What is the ratio of the Educated labor force (% of total) of Spain in 2009 to that in 2011?
Give a very brief answer. 1.05. What is the ratio of the Educated labor force (% of total) of Euro area in 2009 to that in 2012?
Ensure brevity in your answer.  1.08. What is the ratio of the Educated labor force (% of total) of Bosnia and Herzegovina in 2009 to that in 2012?
Provide a short and direct response. 1.12. What is the ratio of the Educated labor force (% of total) of Iceland in 2009 to that in 2012?
Keep it short and to the point. 1.08. What is the ratio of the Educated labor force (% of total) of Spain in 2009 to that in 2012?
Give a very brief answer. 1.06. What is the ratio of the Educated labor force (% of total) in Euro area in 2010 to that in 2011?
Provide a short and direct response. 1.04. What is the ratio of the Educated labor force (% of total) of Bosnia and Herzegovina in 2010 to that in 2011?
Give a very brief answer. 1. What is the ratio of the Educated labor force (% of total) in Iceland in 2010 to that in 2011?
Provide a short and direct response. 1.02. What is the ratio of the Educated labor force (% of total) of Spain in 2010 to that in 2011?
Ensure brevity in your answer.  1.02. What is the ratio of the Educated labor force (% of total) in Euro area in 2010 to that in 2012?
Provide a short and direct response. 1.06. What is the ratio of the Educated labor force (% of total) of Bosnia and Herzegovina in 2010 to that in 2012?
Your answer should be very brief. 1.01. What is the ratio of the Educated labor force (% of total) in Iceland in 2010 to that in 2012?
Your answer should be very brief. 1.06. What is the ratio of the Educated labor force (% of total) in Spain in 2010 to that in 2012?
Offer a terse response. 1.04. What is the ratio of the Educated labor force (% of total) in Euro area in 2011 to that in 2012?
Give a very brief answer. 1.02. What is the ratio of the Educated labor force (% of total) in Bosnia and Herzegovina in 2011 to that in 2012?
Your answer should be compact. 1.01. What is the ratio of the Educated labor force (% of total) in Iceland in 2011 to that in 2012?
Give a very brief answer. 1.04. What is the ratio of the Educated labor force (% of total) in Spain in 2011 to that in 2012?
Provide a short and direct response. 1.01. What is the difference between the highest and the second highest Educated labor force (% of total) in Euro area?
Keep it short and to the point. 0.74. What is the difference between the highest and the second highest Educated labor force (% of total) in Iceland?
Give a very brief answer. 1.3. What is the difference between the highest and the lowest Educated labor force (% of total) in Euro area?
Provide a succinct answer. 4.23. What is the difference between the highest and the lowest Educated labor force (% of total) in Iceland?
Provide a succinct answer. 7.9. What is the difference between the highest and the lowest Educated labor force (% of total) of Spain?
Offer a very short reply. 3.5. 